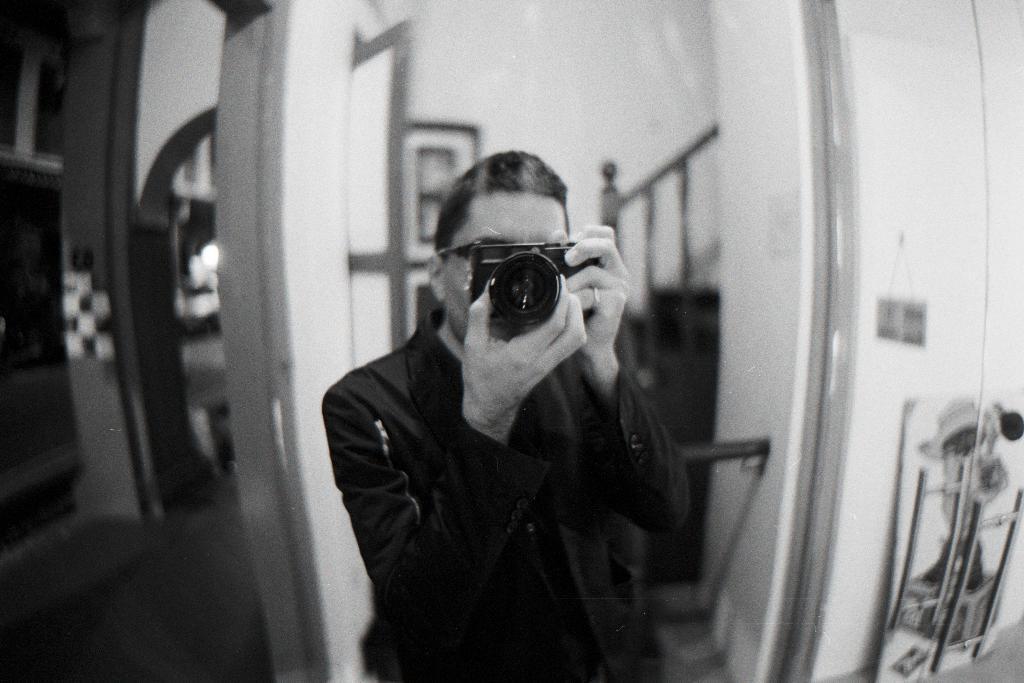Describe this image in one or two sentences. In this picture there is a man holding a camera in his hands wearing a black dress. In the background there is a railing and some photographs attached to the wall. Here, we can observe a stand here. 